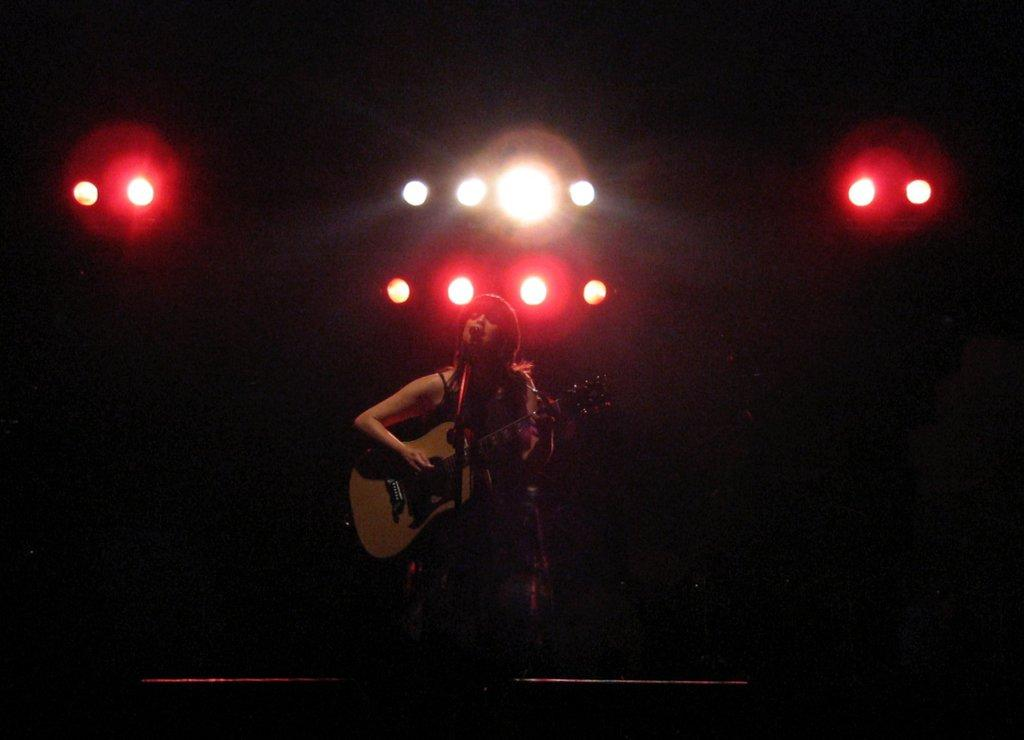What type of lights are present in the image? There are focusing lights in the image. What is the woman doing in the image? The woman is playing a guitar and singing. What device is the woman using to amplify her voice? There is a microphone in the image. What advice does the woman's aunt give her about her guitar playing in the image? There is no mention of an aunt or any advice in the image. How does the woman's coach help her improve her singing in the image? There is no coach or indication of any coaching in the image. 